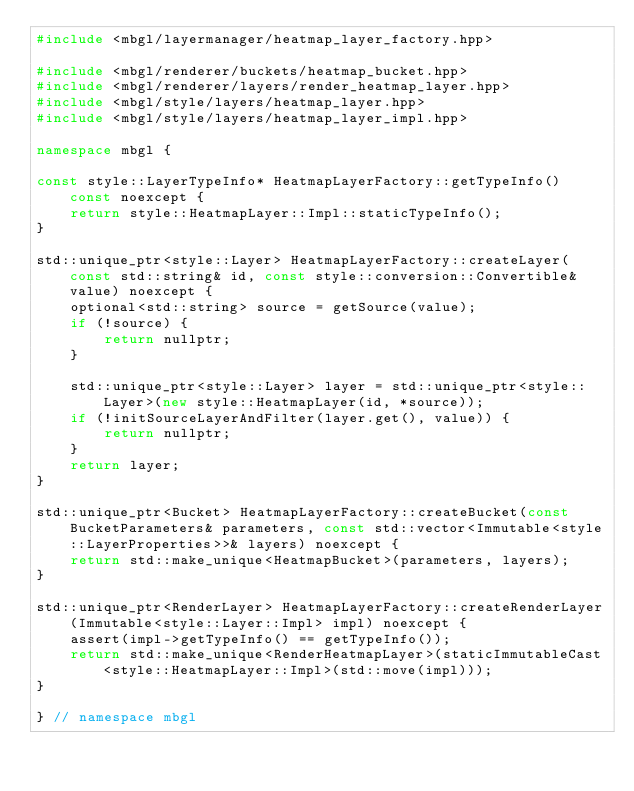Convert code to text. <code><loc_0><loc_0><loc_500><loc_500><_C++_>#include <mbgl/layermanager/heatmap_layer_factory.hpp>

#include <mbgl/renderer/buckets/heatmap_bucket.hpp>
#include <mbgl/renderer/layers/render_heatmap_layer.hpp>
#include <mbgl/style/layers/heatmap_layer.hpp>
#include <mbgl/style/layers/heatmap_layer_impl.hpp>

namespace mbgl {

const style::LayerTypeInfo* HeatmapLayerFactory::getTypeInfo() const noexcept {
    return style::HeatmapLayer::Impl::staticTypeInfo();
}

std::unique_ptr<style::Layer> HeatmapLayerFactory::createLayer(const std::string& id, const style::conversion::Convertible& value) noexcept {
    optional<std::string> source = getSource(value);
    if (!source) {
        return nullptr;
    }

    std::unique_ptr<style::Layer> layer = std::unique_ptr<style::Layer>(new style::HeatmapLayer(id, *source));
    if (!initSourceLayerAndFilter(layer.get(), value)) {
        return nullptr;
    }
    return layer;
}

std::unique_ptr<Bucket> HeatmapLayerFactory::createBucket(const BucketParameters& parameters, const std::vector<Immutable<style::LayerProperties>>& layers) noexcept {
    return std::make_unique<HeatmapBucket>(parameters, layers);
}

std::unique_ptr<RenderLayer> HeatmapLayerFactory::createRenderLayer(Immutable<style::Layer::Impl> impl) noexcept {
    assert(impl->getTypeInfo() == getTypeInfo());
    return std::make_unique<RenderHeatmapLayer>(staticImmutableCast<style::HeatmapLayer::Impl>(std::move(impl)));
}

} // namespace mbgl
</code> 